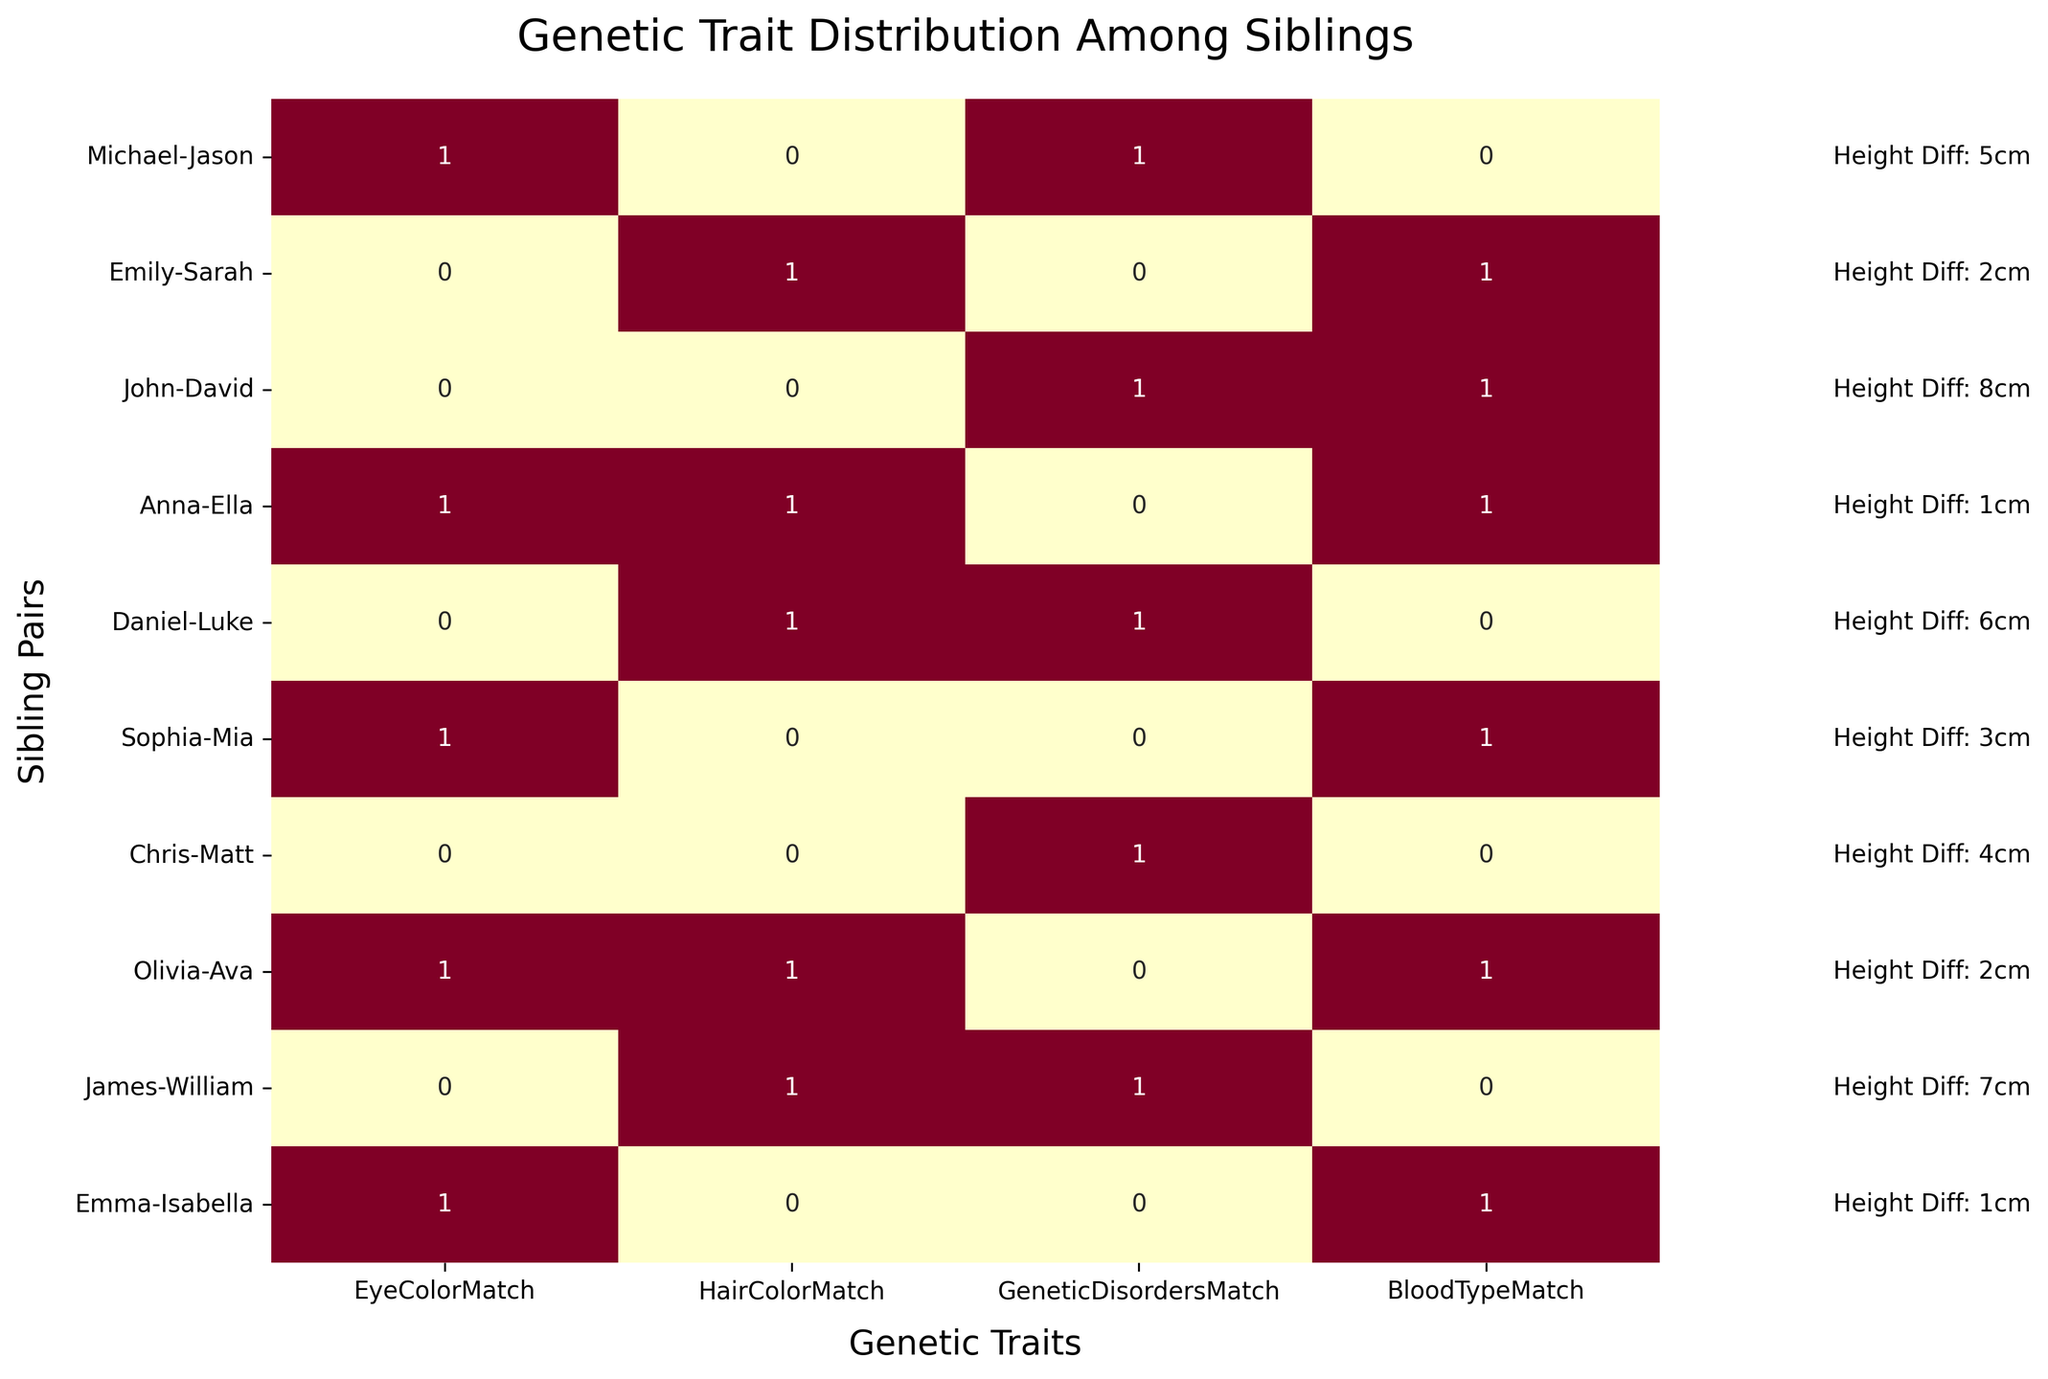What is the title of the heatmap? The title is located at the top of the figure and provides a description of the content of the heatmap.
Answer: Genetic Trait Distribution Among Siblings Which sibling pairs have matching eye color? To find this, look for the cells under the "EyeColorMatch" column with the value "1". The corresponding rows represent the sibling pairs.
Answer: Michael-Jason, Anna-Ella, Olivia-Ava, Emma-Isabella, Sophia-Mia How many pairs have at least one matching genetic disorder? Look for cells under the "GeneticDisordersMatch" column with the value "1". Count the number of such rows to get the answer.
Answer: 4 pairs What is the maximum height difference between the sibling pairs? Check the text annotations beside each row. Identify the highest numerical value among the height differences.
Answer: 8 cm Which sibling pairs have all four genetic traits matched? Check the heatmap and find the row where all four columns ("EyeColorMatch", "HairColorMatch", "GeneticDisordersMatch", "BloodTypeMatch") have the value "1".
Answer: None How does the height difference between Olivia-Ava and John-David compare? Check the text annotations beside the rows of Olivia-Ava and John-David. Olivia-Ava has 2 cm and John-David has 8 cm height difference. Comparing these values shows that John-David has a larger height difference.
Answer: John-David has a larger height difference How many sibling pairs have at least three matching traits? Look for rows where three or more cells under the "EyeColorMatch", "HairColorMatch", "GeneticDisordersMatch", "BloodTypeMatch" columns have the value "1". Count these rows.
Answer: 3 pairs What is the average height difference among all sibling pairs? Add up the height differences from all the sibling pairs, then divide by the total number of pairs. (5 + 2 + 8 + 1 + 6 + 3 + 4 + 2 + 7 + 1) / 10 = 39 / 10 = 3.9 cm
Answer: 3.9 cm Which sibling pair has the least height difference? Check the text annotations beside each row. Identify the sibling pair with the smallest numerical value.
Answer: Anna-Ella and Emma-Isabella How many pairs have their blood types matched? Look for cells under the "BloodTypeMatch" column with the value "1". Count the number of matching cells.
Answer: 5 pairs 